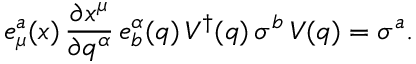Convert formula to latex. <formula><loc_0><loc_0><loc_500><loc_500>e _ { \mu } ^ { a } ( x ) \, \frac { \partial x ^ { \mu } } { \partial q ^ { \alpha } } \, e _ { b } ^ { \alpha } ( q ) \, V ^ { \dagger } ( q ) \, \sigma ^ { b } \, V ( q ) = \sigma ^ { a } .</formula> 